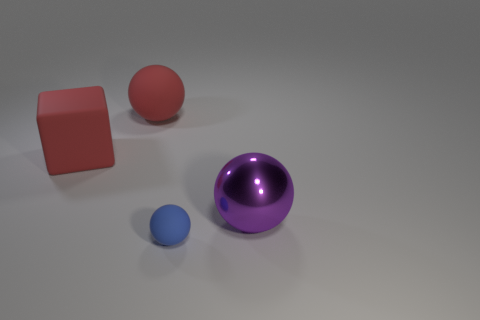Subtract all large red matte spheres. How many spheres are left? 2 Subtract 1 blocks. How many blocks are left? 0 Subtract all red balls. How many balls are left? 2 Subtract all balls. How many objects are left? 1 Add 4 large metal objects. How many objects exist? 8 Subtract all rubber things. Subtract all small blue matte balls. How many objects are left? 0 Add 1 matte things. How many matte things are left? 4 Add 3 shiny spheres. How many shiny spheres exist? 4 Subtract 0 yellow cubes. How many objects are left? 4 Subtract all purple spheres. Subtract all yellow blocks. How many spheres are left? 2 